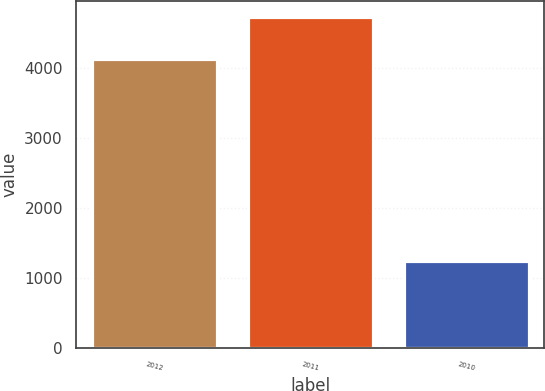Convert chart. <chart><loc_0><loc_0><loc_500><loc_500><bar_chart><fcel>2012<fcel>2011<fcel>2010<nl><fcel>4130<fcel>4716<fcel>1251<nl></chart> 